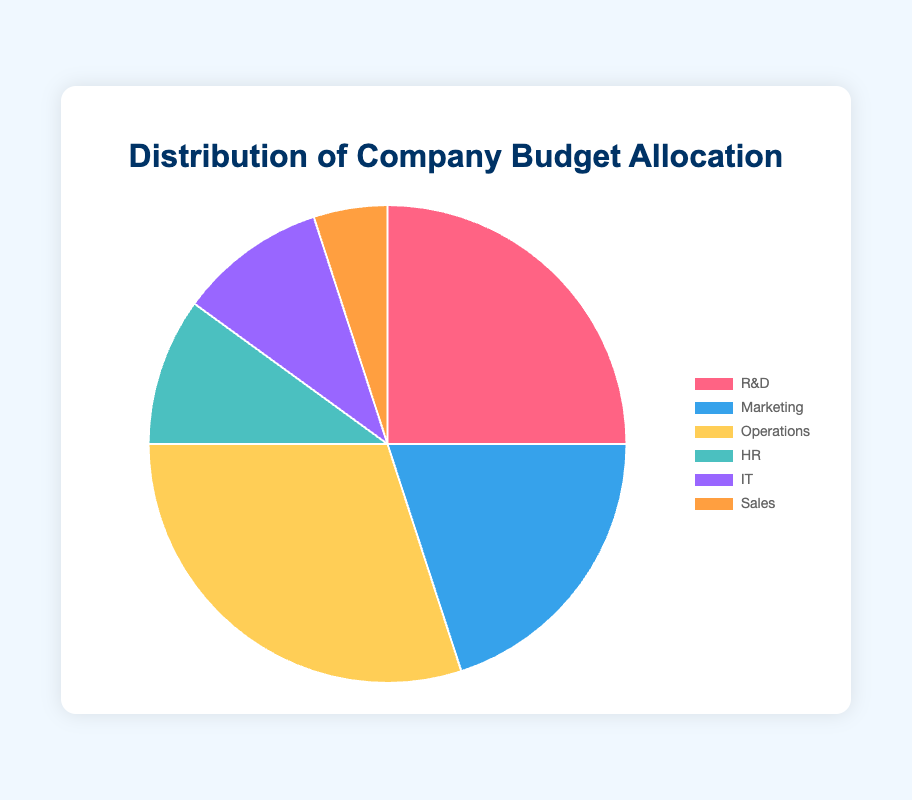What percentage of the budget is allocated to HR and IT combined? First, find the percentages for HR (10%) and IT (10%). Add these two values together: 10% + 10% = 20%.
Answer: 20% Which department receives the highest budget allocation? Examine the percentages for all departments: R&D (25%), Marketing (20%), Operations (30%), HR (10%), IT (10%), and Sales (5%). The highest allocation is for Operations with 30%.
Answer: Operations How much more budget allocation does Operations have compared to Sales? Find the percentages for Operations (30%) and Sales (5%). Subtract the Sales percentage from the Operations percentage: 30% - 5% = 25%.
Answer: 25% Which two departments have an equal budget allocation? Review the percentage allocations for all departments. HR and IT both have an allocation of 10%.
Answer: HR and IT What fraction of the total budget is allocated to R&D? The percentage of the budget allocated to R&D is 25%. To convert this to a fraction, 25% = 25/100 = 1/4.
Answer: 1/4 What is the difference in budget allocation between R&D and Marketing combined and Operations? First, add the allocations for R&D (25%) and Marketing (20%): 25% + 20% = 45%. Then, find the difference between this combined allocation and Operations' allocation (30%): 45% - 30% = 15%.
Answer: 15% Which department's budget allocation is represented by the light blue section of the pie chart? Referring to the color information provided, Marketing is represented by light blue.
Answer: Marketing If the company decides to increase the Sales budget by 5%, what will be the new budget allocation for Sales? The current allocation for Sales is 5%. If it increases by 5%, the new allocation will be 5% + 5% = 10%.
Answer: 10% What percentage of the budget is allocated to departments other than Operations? First, find the total percentage excluding Operations (30%): R&D (25%) + Marketing (20%) + HR (10%) + IT (10%) + Sales (5%) = 70%.
Answer: 70% What is the average budget allocation per department? Sum the percentages for all departments: 25% + 20% + 30% + 10% + 10% + 5% = 100%. There are 6 departments, so divide the total by 6: 100% / 6 ≈ 16.67%.
Answer: 16.67% 